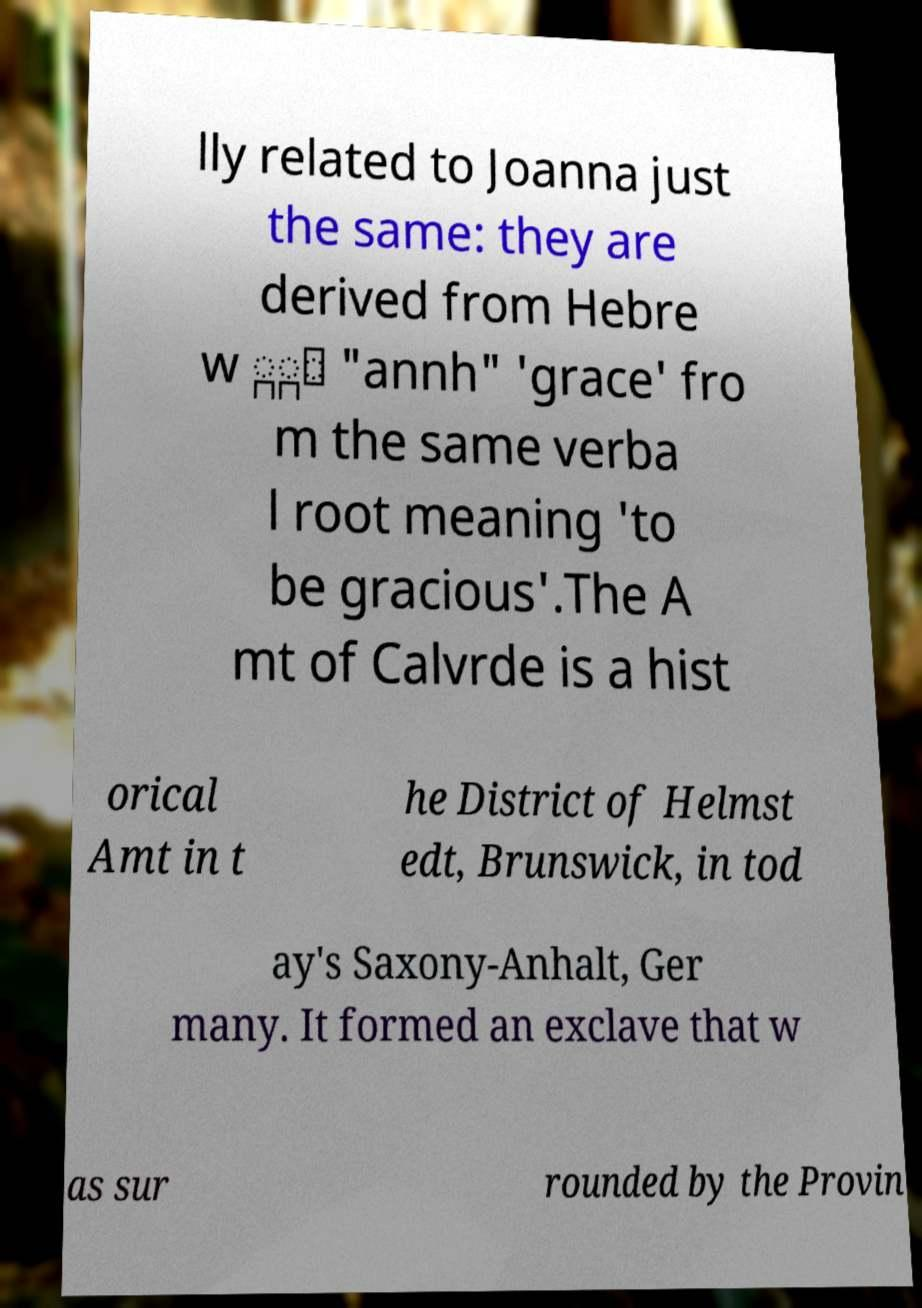Please identify and transcribe the text found in this image. lly related to Joanna just the same: they are derived from Hebre w ַָּ "annh" 'grace' fro m the same verba l root meaning 'to be gracious'.The A mt of Calvrde is a hist orical Amt in t he District of Helmst edt, Brunswick, in tod ay's Saxony-Anhalt, Ger many. It formed an exclave that w as sur rounded by the Provin 